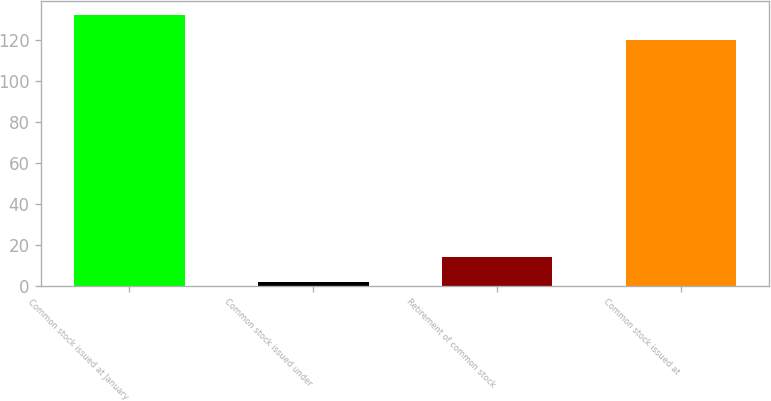Convert chart. <chart><loc_0><loc_0><loc_500><loc_500><bar_chart><fcel>Common stock issued at January<fcel>Common stock issued under<fcel>Retirement of common stock<fcel>Common stock issued at<nl><fcel>132.26<fcel>1.9<fcel>14.16<fcel>120<nl></chart> 